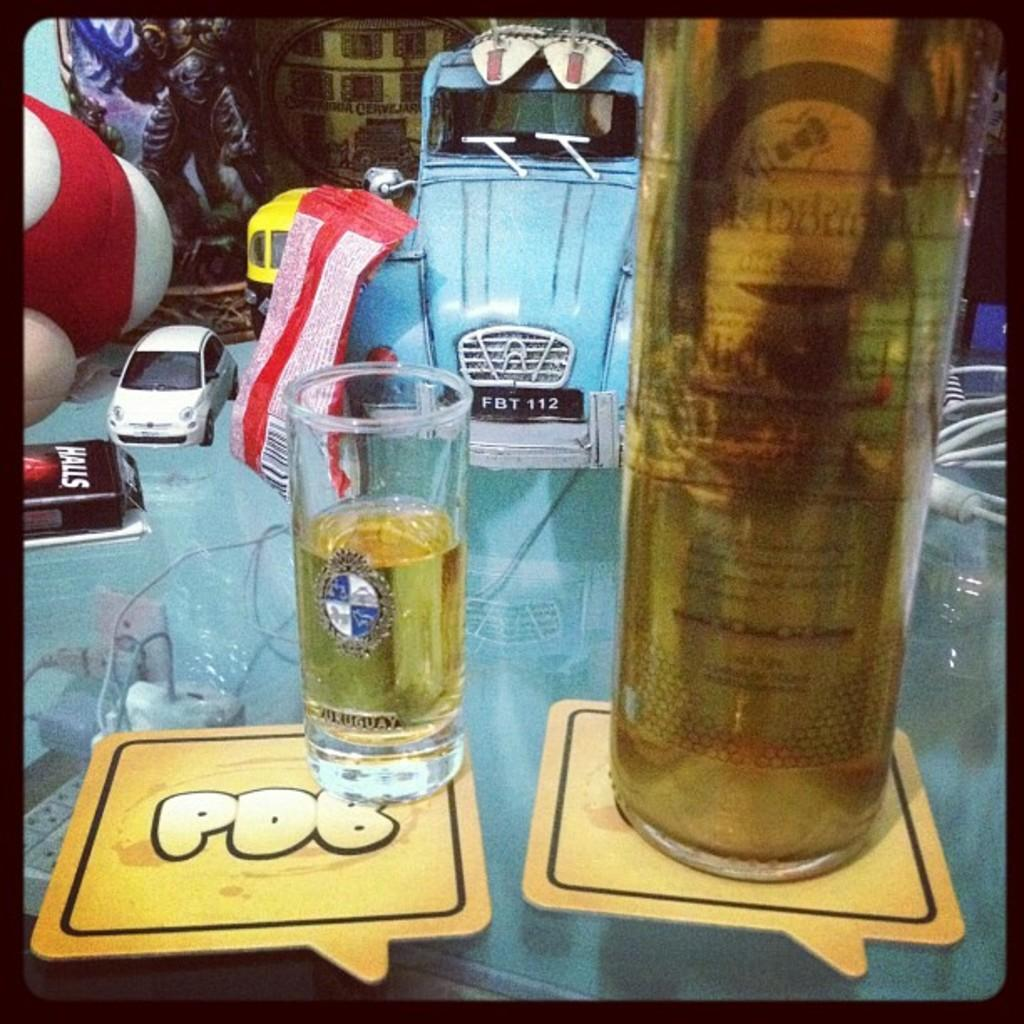<image>
Relay a brief, clear account of the picture shown. A glass of wine sits atop a PDB coaster. 